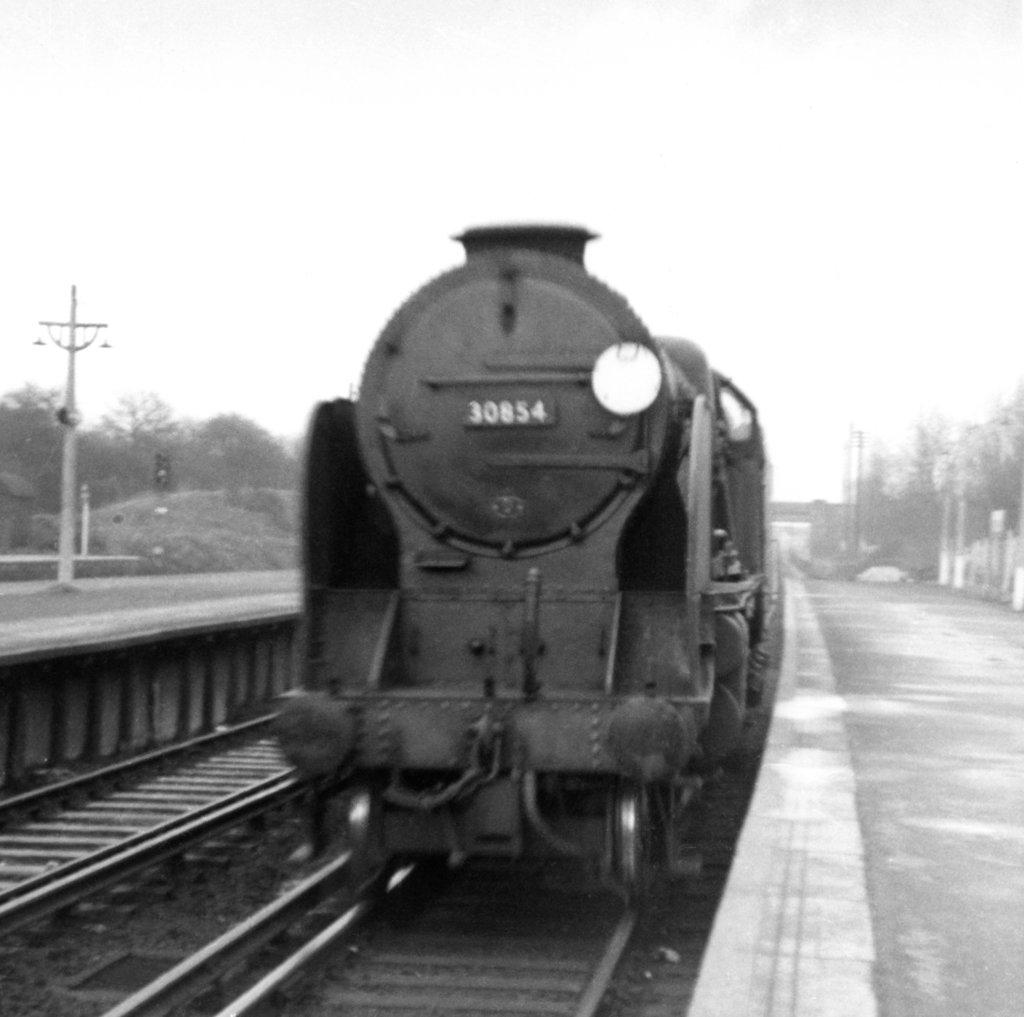What is the main subject of the image? The main subject of the image is a train. Can you describe the train's position in the image? The train is on a track. What is located on the left side of the image? There is a pole on the left side of the image. What can be seen in the background of the image? There are trees and the sky visible in the background of the image. What type of zipper can be seen on the train in the image? There is no zipper present on the train in the image. How many hens are visible in the field behind the train? There is no field or hen present in the image; it features a train on a track with a pole on the left side and trees and the sky in the background. 